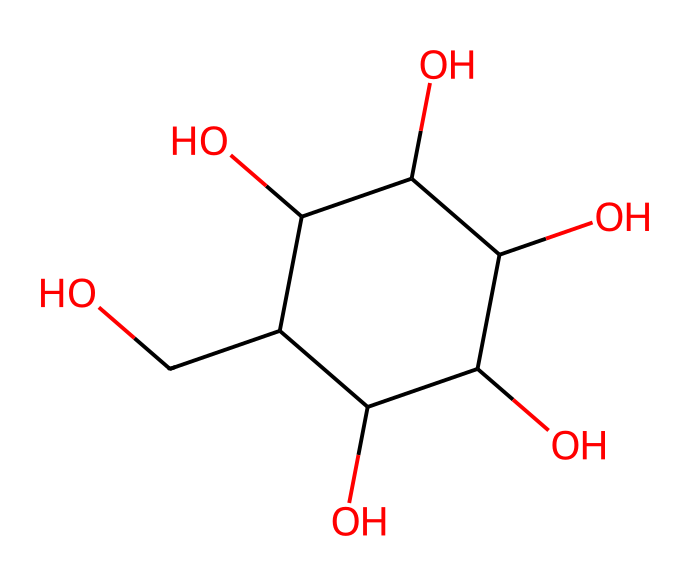What is the molecular formula of this compound? To find the molecular formula, we count all the atoms of carbon (C), hydrogen (H), and oxygen (O). The structure shows 6 carbons, 12 hydrogens, and 6 oxygens. This gives us a formula of C6H12O6.
Answer: C6H12O6 How many hydroxyl (–OH) groups are present in the molecule? By inspecting the structure of the chemical, we can identify that there are 5 hydroxyl groups (–OH) attached to the carbon atoms in the ring.
Answer: 5 What type of isomer is glucose classified as? Glucose is classified as an aldose due to the presence of an aldehyde group in its structure. This can be seen from the arrangement of the functional groups in the molecule.
Answer: aldose What property makes glucose a non-electrolyte? Glucose does not dissociate into ions in solution, which is a characteristic of non-electrolytes. The molecule remains intact as a whole when dissolved in water, leading to no electrical conductivity.
Answer: does not dissociate What mechanism contributes to the solubility of glucose in water? The hydroxyl groups in glucose can form hydrogen bonds with water, enhancing its solubility. This capability is evident from the multiple –OH groups present in the structure.
Answer: hydrogen bonding How does the molecular arrangement of glucose contribute to its sweetness? The specific arrangement of hydroxyl groups and the aldehyde group in glucose interacts with our taste receptors, resulting in its characteristic sweetness. This can be inferred from the molecular structure which highlights these functional groups.
Answer: functional groups 